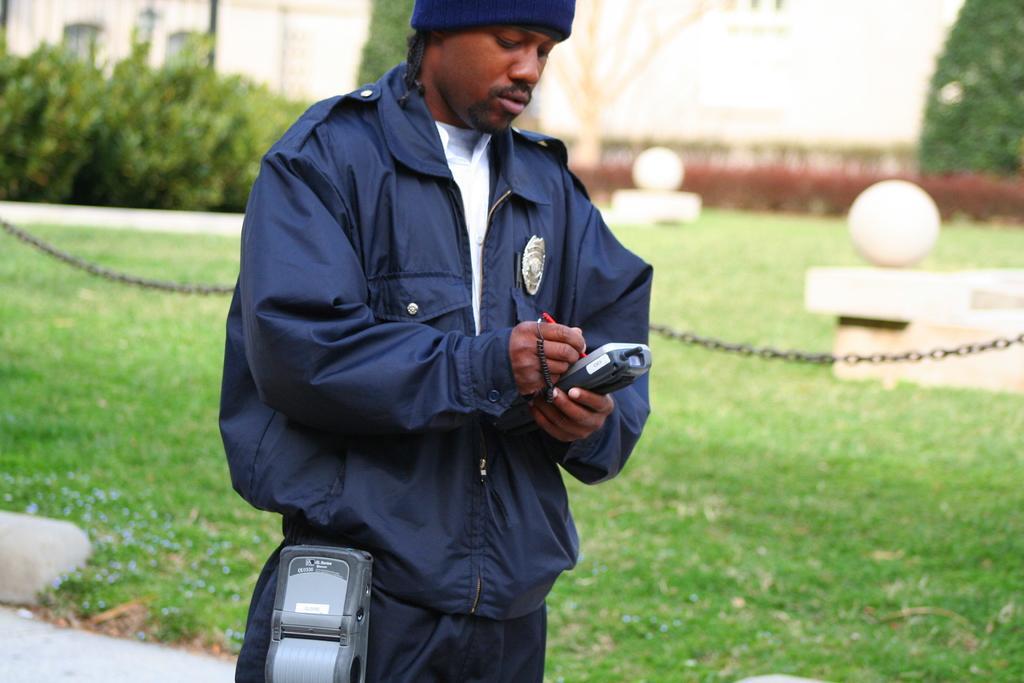Please provide a concise description of this image. In this image we can see a man is standing and holding objects in the hands and there is an electronic device. In the background we can see grass on the ground, chain, pole, wall, plants and objects. 